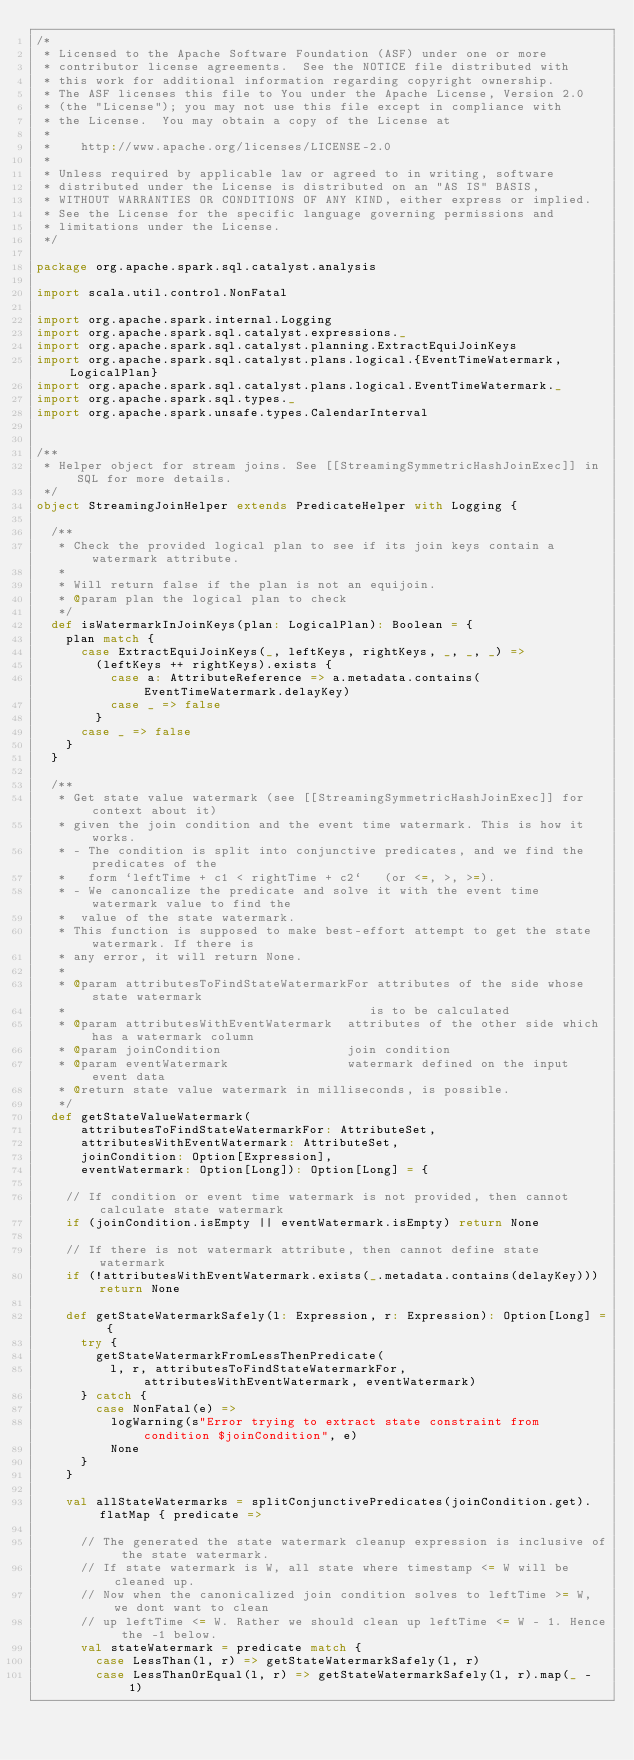Convert code to text. <code><loc_0><loc_0><loc_500><loc_500><_Scala_>/*
 * Licensed to the Apache Software Foundation (ASF) under one or more
 * contributor license agreements.  See the NOTICE file distributed with
 * this work for additional information regarding copyright ownership.
 * The ASF licenses this file to You under the Apache License, Version 2.0
 * (the "License"); you may not use this file except in compliance with
 * the License.  You may obtain a copy of the License at
 *
 *    http://www.apache.org/licenses/LICENSE-2.0
 *
 * Unless required by applicable law or agreed to in writing, software
 * distributed under the License is distributed on an "AS IS" BASIS,
 * WITHOUT WARRANTIES OR CONDITIONS OF ANY KIND, either express or implied.
 * See the License for the specific language governing permissions and
 * limitations under the License.
 */

package org.apache.spark.sql.catalyst.analysis

import scala.util.control.NonFatal

import org.apache.spark.internal.Logging
import org.apache.spark.sql.catalyst.expressions._
import org.apache.spark.sql.catalyst.planning.ExtractEquiJoinKeys
import org.apache.spark.sql.catalyst.plans.logical.{EventTimeWatermark, LogicalPlan}
import org.apache.spark.sql.catalyst.plans.logical.EventTimeWatermark._
import org.apache.spark.sql.types._
import org.apache.spark.unsafe.types.CalendarInterval


/**
 * Helper object for stream joins. See [[StreamingSymmetricHashJoinExec]] in SQL for more details.
 */
object StreamingJoinHelper extends PredicateHelper with Logging {

  /**
   * Check the provided logical plan to see if its join keys contain a watermark attribute.
   *
   * Will return false if the plan is not an equijoin.
   * @param plan the logical plan to check
   */
  def isWatermarkInJoinKeys(plan: LogicalPlan): Boolean = {
    plan match {
      case ExtractEquiJoinKeys(_, leftKeys, rightKeys, _, _, _) =>
        (leftKeys ++ rightKeys).exists {
          case a: AttributeReference => a.metadata.contains(EventTimeWatermark.delayKey)
          case _ => false
        }
      case _ => false
    }
  }

  /**
   * Get state value watermark (see [[StreamingSymmetricHashJoinExec]] for context about it)
   * given the join condition and the event time watermark. This is how it works.
   * - The condition is split into conjunctive predicates, and we find the predicates of the
   *   form `leftTime + c1 < rightTime + c2`   (or <=, >, >=).
   * - We canoncalize the predicate and solve it with the event time watermark value to find the
   *  value of the state watermark.
   * This function is supposed to make best-effort attempt to get the state watermark. If there is
   * any error, it will return None.
   *
   * @param attributesToFindStateWatermarkFor attributes of the side whose state watermark
   *                                         is to be calculated
   * @param attributesWithEventWatermark  attributes of the other side which has a watermark column
   * @param joinCondition                 join condition
   * @param eventWatermark                watermark defined on the input event data
   * @return state value watermark in milliseconds, is possible.
   */
  def getStateValueWatermark(
      attributesToFindStateWatermarkFor: AttributeSet,
      attributesWithEventWatermark: AttributeSet,
      joinCondition: Option[Expression],
      eventWatermark: Option[Long]): Option[Long] = {

    // If condition or event time watermark is not provided, then cannot calculate state watermark
    if (joinCondition.isEmpty || eventWatermark.isEmpty) return None

    // If there is not watermark attribute, then cannot define state watermark
    if (!attributesWithEventWatermark.exists(_.metadata.contains(delayKey))) return None

    def getStateWatermarkSafely(l: Expression, r: Expression): Option[Long] = {
      try {
        getStateWatermarkFromLessThenPredicate(
          l, r, attributesToFindStateWatermarkFor, attributesWithEventWatermark, eventWatermark)
      } catch {
        case NonFatal(e) =>
          logWarning(s"Error trying to extract state constraint from condition $joinCondition", e)
          None
      }
    }

    val allStateWatermarks = splitConjunctivePredicates(joinCondition.get).flatMap { predicate =>

      // The generated the state watermark cleanup expression is inclusive of the state watermark.
      // If state watermark is W, all state where timestamp <= W will be cleaned up.
      // Now when the canonicalized join condition solves to leftTime >= W, we dont want to clean
      // up leftTime <= W. Rather we should clean up leftTime <= W - 1. Hence the -1 below.
      val stateWatermark = predicate match {
        case LessThan(l, r) => getStateWatermarkSafely(l, r)
        case LessThanOrEqual(l, r) => getStateWatermarkSafely(l, r).map(_ - 1)</code> 